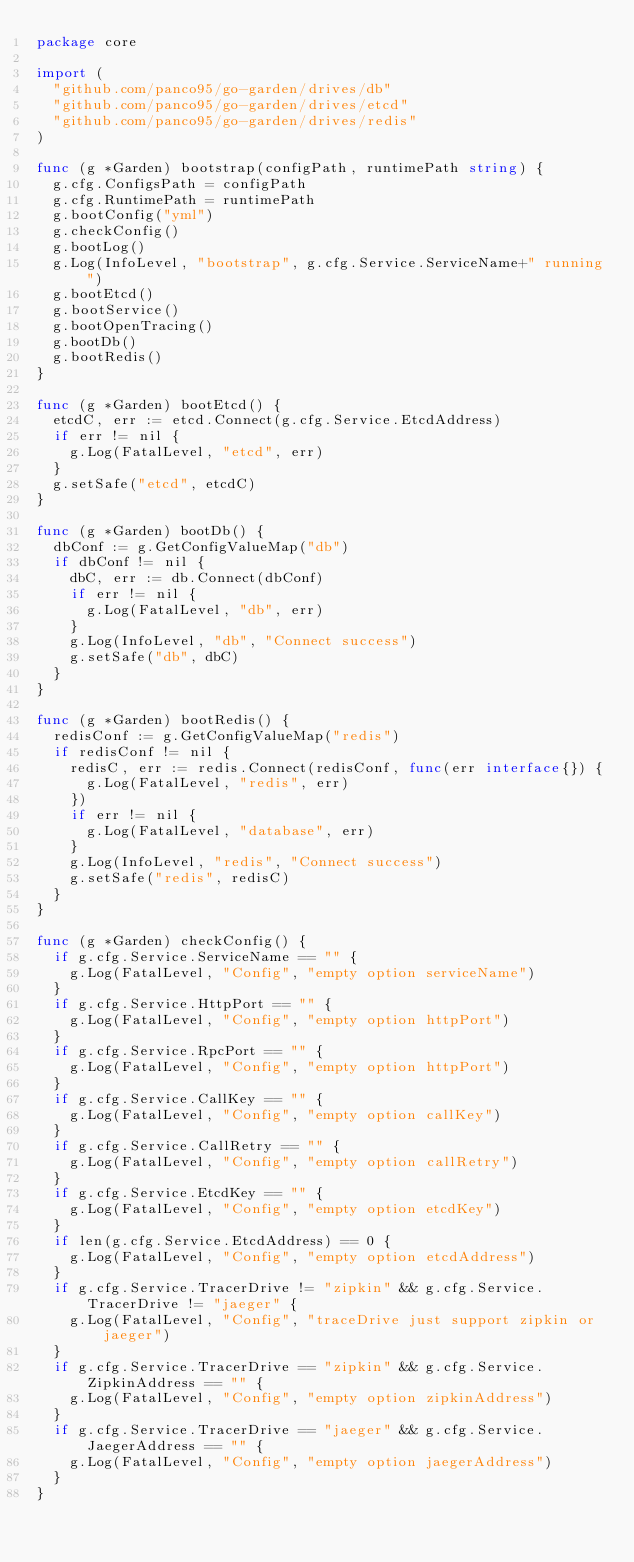<code> <loc_0><loc_0><loc_500><loc_500><_Go_>package core

import (
	"github.com/panco95/go-garden/drives/db"
	"github.com/panco95/go-garden/drives/etcd"
	"github.com/panco95/go-garden/drives/redis"
)

func (g *Garden) bootstrap(configPath, runtimePath string) {
	g.cfg.ConfigsPath = configPath
	g.cfg.RuntimePath = runtimePath
	g.bootConfig("yml")
	g.checkConfig()
	g.bootLog()
	g.Log(InfoLevel, "bootstrap", g.cfg.Service.ServiceName+" running")
	g.bootEtcd()
	g.bootService()
	g.bootOpenTracing()
	g.bootDb()
	g.bootRedis()
}

func (g *Garden) bootEtcd() {
	etcdC, err := etcd.Connect(g.cfg.Service.EtcdAddress)
	if err != nil {
		g.Log(FatalLevel, "etcd", err)
	}
	g.setSafe("etcd", etcdC)
}

func (g *Garden) bootDb() {
	dbConf := g.GetConfigValueMap("db")
	if dbConf != nil {
		dbC, err := db.Connect(dbConf)
		if err != nil {
			g.Log(FatalLevel, "db", err)
		}
		g.Log(InfoLevel, "db", "Connect success")
		g.setSafe("db", dbC)
	}
}

func (g *Garden) bootRedis() {
	redisConf := g.GetConfigValueMap("redis")
	if redisConf != nil {
		redisC, err := redis.Connect(redisConf, func(err interface{}) {
			g.Log(FatalLevel, "redis", err)
		})
		if err != nil {
			g.Log(FatalLevel, "database", err)
		}
		g.Log(InfoLevel, "redis", "Connect success")
		g.setSafe("redis", redisC)
	}
}

func (g *Garden) checkConfig() {
	if g.cfg.Service.ServiceName == "" {
		g.Log(FatalLevel, "Config", "empty option serviceName")
	}
	if g.cfg.Service.HttpPort == "" {
		g.Log(FatalLevel, "Config", "empty option httpPort")
	}
	if g.cfg.Service.RpcPort == "" {
		g.Log(FatalLevel, "Config", "empty option httpPort")
	}
	if g.cfg.Service.CallKey == "" {
		g.Log(FatalLevel, "Config", "empty option callKey")
	}
	if g.cfg.Service.CallRetry == "" {
		g.Log(FatalLevel, "Config", "empty option callRetry")
	}
	if g.cfg.Service.EtcdKey == "" {
		g.Log(FatalLevel, "Config", "empty option etcdKey")
	}
	if len(g.cfg.Service.EtcdAddress) == 0 {
		g.Log(FatalLevel, "Config", "empty option etcdAddress")
	}
	if g.cfg.Service.TracerDrive != "zipkin" && g.cfg.Service.TracerDrive != "jaeger" {
		g.Log(FatalLevel, "Config", "traceDrive just support zipkin or jaeger")
	}
	if g.cfg.Service.TracerDrive == "zipkin" && g.cfg.Service.ZipkinAddress == "" {
		g.Log(FatalLevel, "Config", "empty option zipkinAddress")
	}
	if g.cfg.Service.TracerDrive == "jaeger" && g.cfg.Service.JaegerAddress == "" {
		g.Log(FatalLevel, "Config", "empty option jaegerAddress")
	}
}
</code> 